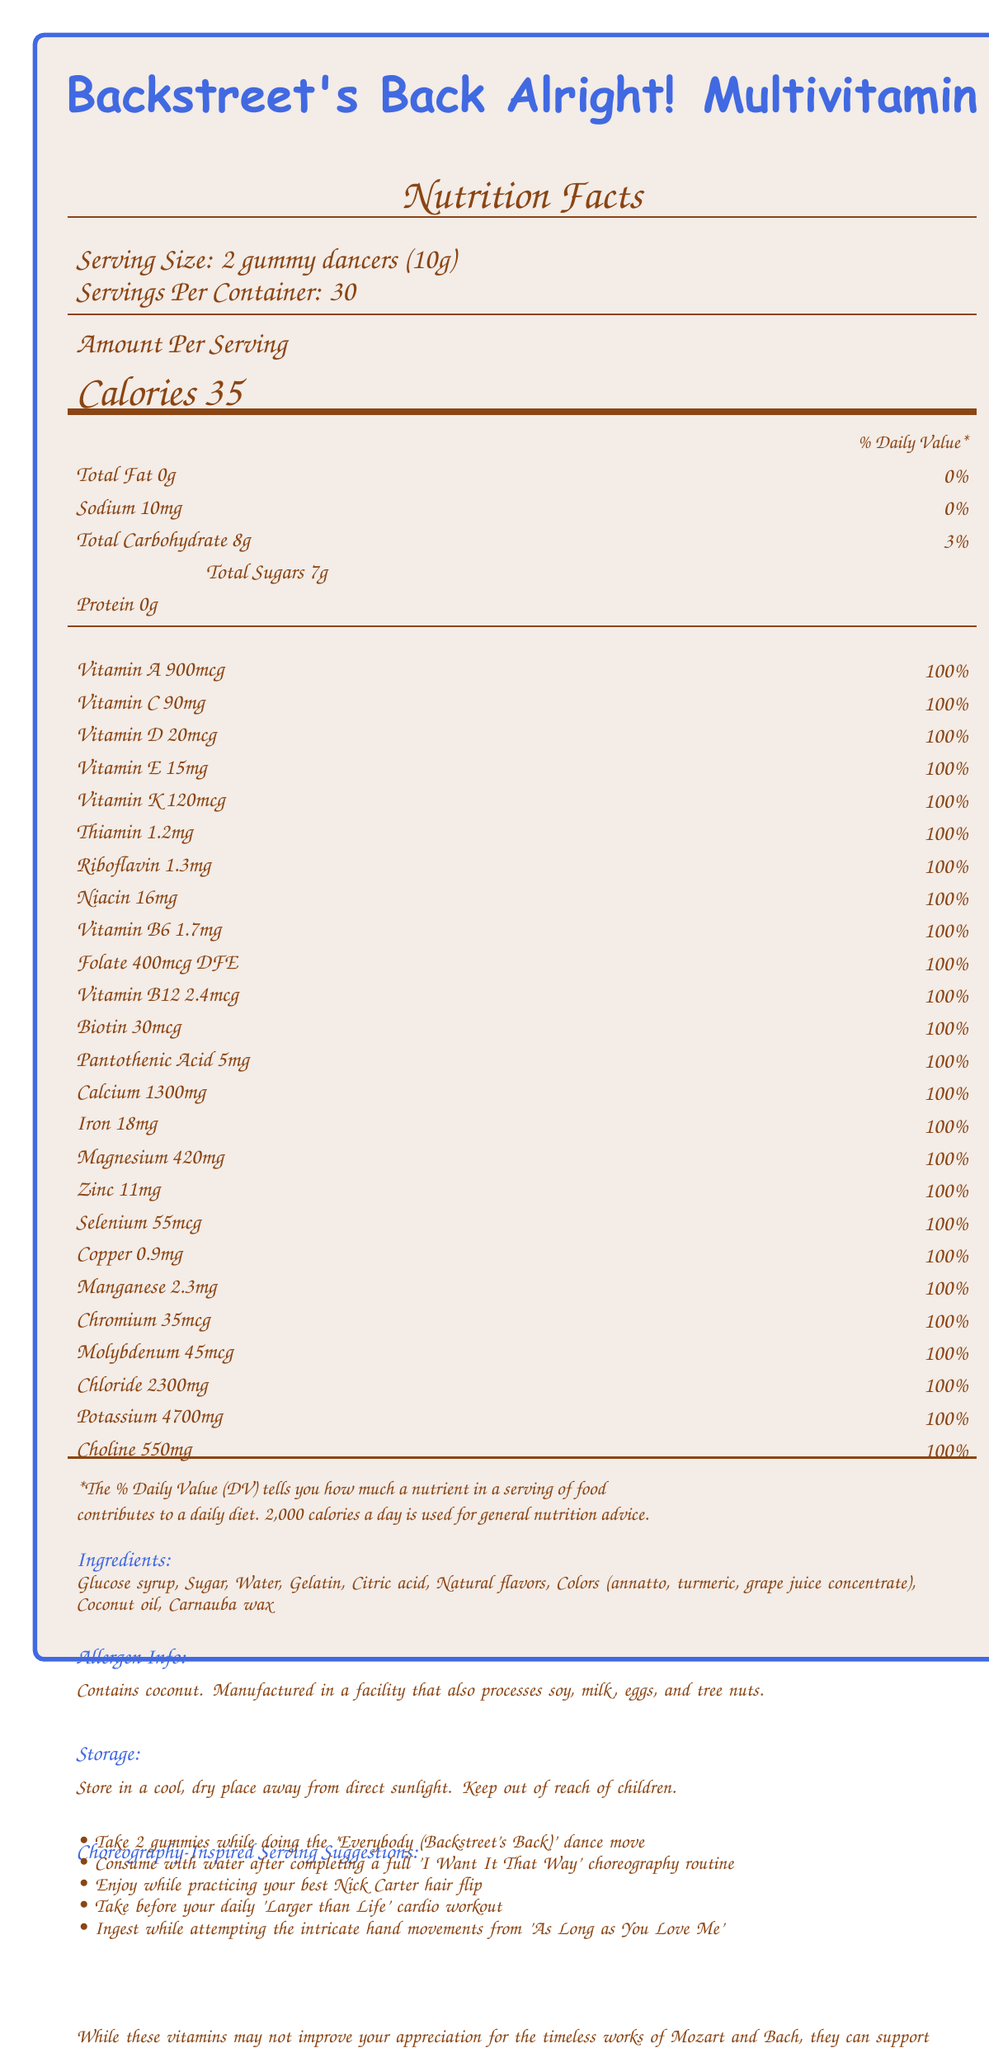what is the serving size of the multivitamin? The document specifies that the serving size is 2 gummy dancers, which together weigh 10g.
Answer: 2 gummy dancers (10g) how many calories are in each serving? The document states that each serving contains 35 calories.
Answer: 35 calories what percentage of the daily value of vitamin A does one serving provide? According to the document, one serving of the vitamin supplement provides 100% of the daily value for vitamin A.
Answer: 100% what are two of the main ingredients in the multivitamin? The document lists glucose syrup and sugar among the main ingredients.
Answer: Glucose syrup, Sugar can you store the multivitamin in a humid place? The storage instructions in the document advise to store the vitamins in a cool, dry place away from direct sunlight.
Answer: No which choreographed dance move is suggested for consuming two gummies? A. 'I Want It That Way' routine B. 'Everybody (Backstreet's Back)' dance move C. 'Larger than Life' cardio workout The document suggests taking 2 gummies while doing the 'Everybody (Backstreet's Back)' dance move.
Answer: B. 'Everybody (Backstreet's Back)' dance move how many servings per container are there? A. 15 B. 20 C. 25 D. 30 The document states that there are 30 servings per container.
Answer: D. 30 does the product contain soy ingredients? According to the allergen information, the product contains coconut and is manufactured in a facility that also processes soy, but it does not indicate that soy is an ingredient in the product itself.
Answer: No summarize the main idea of this document. The document includes important details such as the nutritional content per serving, % daily values of nutrients, ingredients, allergens, and special instructions for taking the supplement aligned with boy band dance routines. Additionally, it mentions that the product supports overall health without improving appreciation for Mozart and Bach.
Answer: The document provides detailed nutritional information for the "Backstreet's Back Alright! Multivitamin" including serving size, daily values for various vitamins and minerals, ingredients, allergen information, storage instructions, and fun choreography-inspired serving suggestions. what is the total carbohydrate content per serving? The document mentions that each serving contains 8g of total carbohydrates.
Answer: 8g how much vitamin D does each serving provide? Each serving provides 20mcg of vitamin D, which is 100% of the daily value.
Answer: 20mcg how should you practice consuming the vitamins before a workout? The document suggests taking the vitamins before performing the 'Larger than Life' cardio workout.
Answer: Take before your daily 'Larger than Life' cardio workout how many mg of sodium are in each serving? The nutritional information specifies there are 10mg of sodium per serving.
Answer: 10mg does the product cater to improving appreciation for classical music? The document humorously states that the vitamins may not improve appreciation for Mozart and Bach, but they can support overall health.
Answer: No which type of natural flavors are included in the multivitamin? The document only mentions "natural flavors" without specifying the types of natural flavors included.
Answer: Cannot be determined 